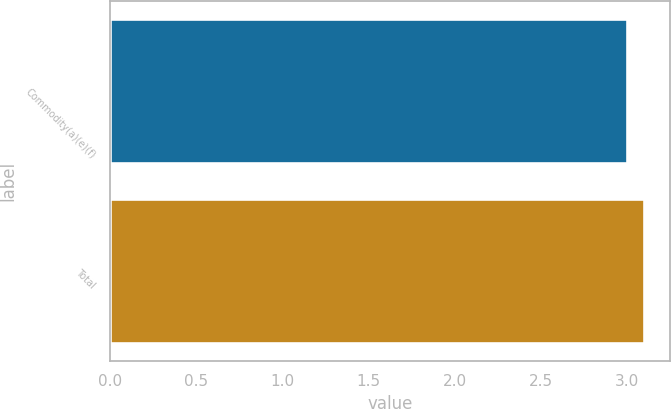<chart> <loc_0><loc_0><loc_500><loc_500><bar_chart><fcel>Commodity(a)(e)(f)<fcel>Total<nl><fcel>3<fcel>3.1<nl></chart> 